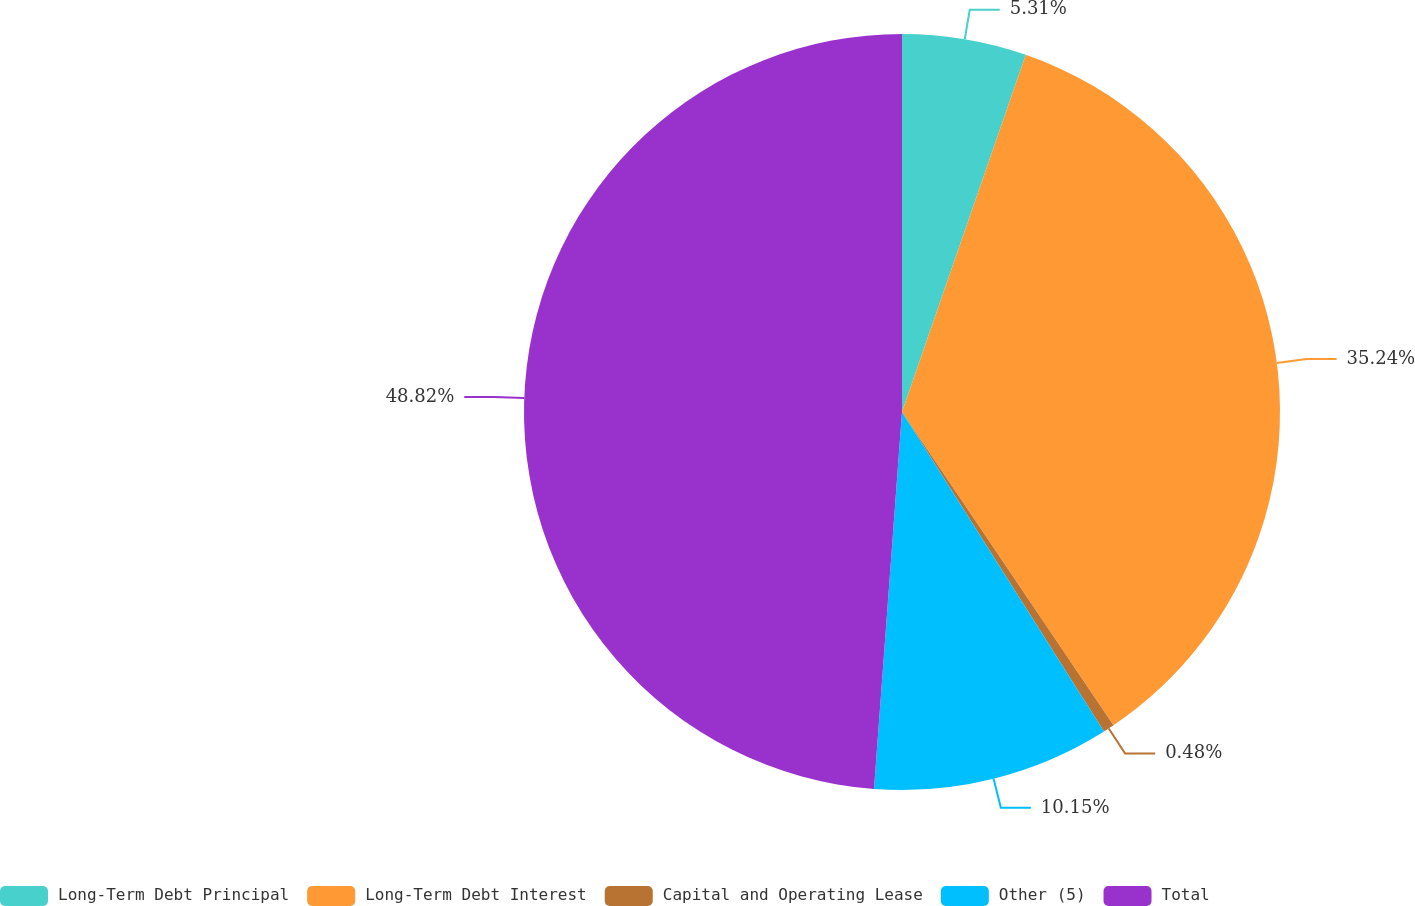Convert chart. <chart><loc_0><loc_0><loc_500><loc_500><pie_chart><fcel>Long-Term Debt Principal<fcel>Long-Term Debt Interest<fcel>Capital and Operating Lease<fcel>Other (5)<fcel>Total<nl><fcel>5.31%<fcel>35.24%<fcel>0.48%<fcel>10.15%<fcel>48.82%<nl></chart> 